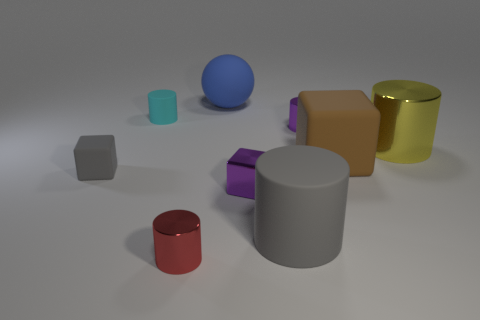Is there anything else that has the same shape as the big blue thing?
Ensure brevity in your answer.  No. Is the material of the brown thing the same as the purple cylinder that is in front of the large blue thing?
Offer a very short reply. No. There is a tiny object to the right of the big matte cylinder; does it have the same shape as the yellow metallic thing?
Offer a very short reply. Yes. What number of large gray objects have the same material as the gray cylinder?
Keep it short and to the point. 0. What number of objects are either gray rubber objects that are on the left side of the big sphere or small purple cubes?
Provide a short and direct response. 2. What is the size of the cyan object?
Keep it short and to the point. Small. The small cylinder in front of the large cylinder to the right of the tiny purple cylinder is made of what material?
Offer a very short reply. Metal. Does the gray matte object to the right of the red cylinder have the same size as the tiny red shiny cylinder?
Ensure brevity in your answer.  No. Are there any tiny metallic objects that have the same color as the metal block?
Your answer should be compact. Yes. How many objects are either small purple objects behind the tiny gray rubber thing or things that are to the left of the large blue matte ball?
Offer a terse response. 4. 